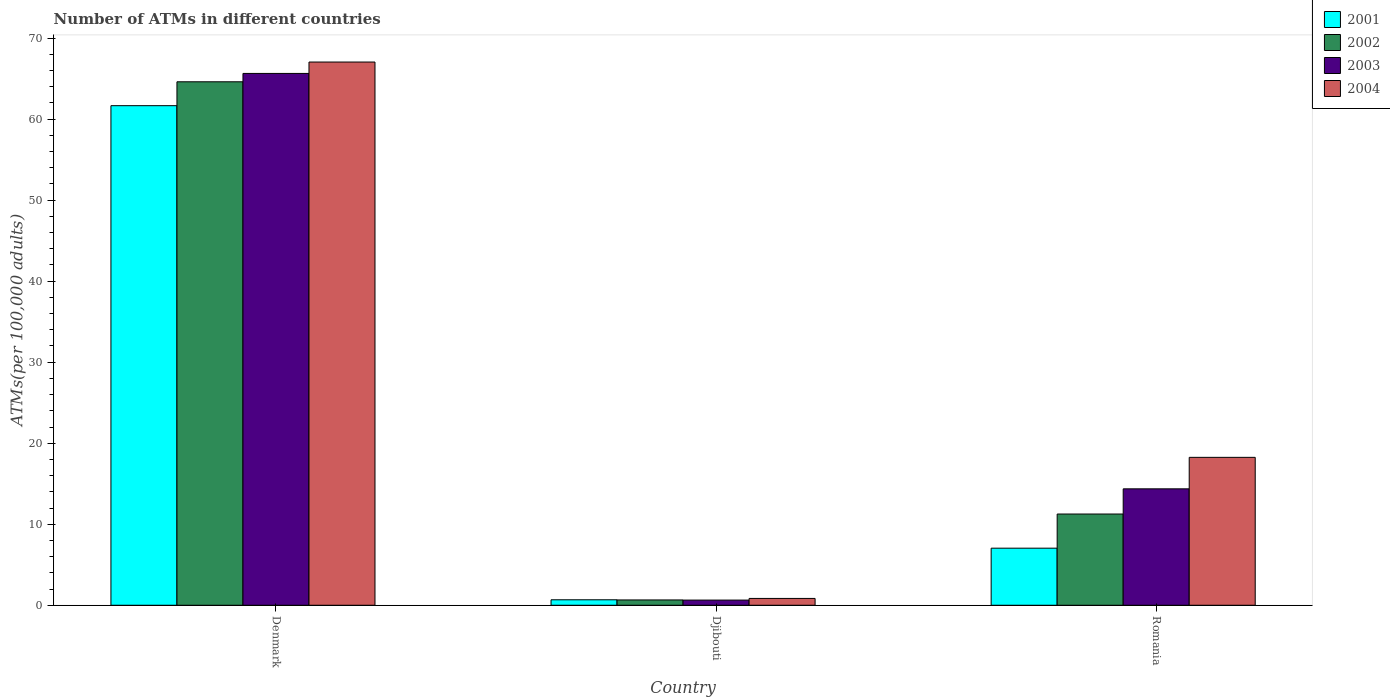How many different coloured bars are there?
Your answer should be very brief. 4. How many groups of bars are there?
Give a very brief answer. 3. Are the number of bars per tick equal to the number of legend labels?
Ensure brevity in your answer.  Yes. How many bars are there on the 1st tick from the right?
Ensure brevity in your answer.  4. In how many cases, is the number of bars for a given country not equal to the number of legend labels?
Your answer should be very brief. 0. What is the number of ATMs in 2001 in Romania?
Your answer should be very brief. 7.04. Across all countries, what is the maximum number of ATMs in 2001?
Keep it short and to the point. 61.66. Across all countries, what is the minimum number of ATMs in 2004?
Make the answer very short. 0.84. In which country was the number of ATMs in 2001 maximum?
Give a very brief answer. Denmark. In which country was the number of ATMs in 2001 minimum?
Provide a short and direct response. Djibouti. What is the total number of ATMs in 2004 in the graph?
Make the answer very short. 86.14. What is the difference between the number of ATMs in 2004 in Denmark and that in Romania?
Offer a terse response. 48.79. What is the difference between the number of ATMs in 2004 in Denmark and the number of ATMs in 2003 in Romania?
Give a very brief answer. 52.67. What is the average number of ATMs in 2002 per country?
Your answer should be compact. 25.51. What is the difference between the number of ATMs of/in 2004 and number of ATMs of/in 2002 in Romania?
Keep it short and to the point. 7. In how many countries, is the number of ATMs in 2001 greater than 34?
Give a very brief answer. 1. What is the ratio of the number of ATMs in 2002 in Denmark to that in Romania?
Your answer should be compact. 5.74. Is the number of ATMs in 2003 in Denmark less than that in Romania?
Your answer should be very brief. No. What is the difference between the highest and the second highest number of ATMs in 2001?
Keep it short and to the point. -60.98. What is the difference between the highest and the lowest number of ATMs in 2002?
Give a very brief answer. 63.95. Is the sum of the number of ATMs in 2003 in Djibouti and Romania greater than the maximum number of ATMs in 2004 across all countries?
Keep it short and to the point. No. Is it the case that in every country, the sum of the number of ATMs in 2003 and number of ATMs in 2001 is greater than the sum of number of ATMs in 2002 and number of ATMs in 2004?
Provide a short and direct response. No. What does the 1st bar from the left in Denmark represents?
Ensure brevity in your answer.  2001. What does the 2nd bar from the right in Denmark represents?
Keep it short and to the point. 2003. Is it the case that in every country, the sum of the number of ATMs in 2002 and number of ATMs in 2004 is greater than the number of ATMs in 2003?
Offer a very short reply. Yes. Are all the bars in the graph horizontal?
Offer a terse response. No. What is the difference between two consecutive major ticks on the Y-axis?
Make the answer very short. 10. Are the values on the major ticks of Y-axis written in scientific E-notation?
Provide a short and direct response. No. How many legend labels are there?
Keep it short and to the point. 4. How are the legend labels stacked?
Give a very brief answer. Vertical. What is the title of the graph?
Offer a terse response. Number of ATMs in different countries. What is the label or title of the X-axis?
Your answer should be very brief. Country. What is the label or title of the Y-axis?
Provide a short and direct response. ATMs(per 100,0 adults). What is the ATMs(per 100,000 adults) of 2001 in Denmark?
Provide a short and direct response. 61.66. What is the ATMs(per 100,000 adults) of 2002 in Denmark?
Provide a succinct answer. 64.61. What is the ATMs(per 100,000 adults) of 2003 in Denmark?
Provide a succinct answer. 65.64. What is the ATMs(per 100,000 adults) in 2004 in Denmark?
Offer a terse response. 67.04. What is the ATMs(per 100,000 adults) in 2001 in Djibouti?
Give a very brief answer. 0.68. What is the ATMs(per 100,000 adults) in 2002 in Djibouti?
Your answer should be very brief. 0.66. What is the ATMs(per 100,000 adults) in 2003 in Djibouti?
Your response must be concise. 0.64. What is the ATMs(per 100,000 adults) in 2004 in Djibouti?
Your answer should be compact. 0.84. What is the ATMs(per 100,000 adults) in 2001 in Romania?
Give a very brief answer. 7.04. What is the ATMs(per 100,000 adults) of 2002 in Romania?
Your answer should be compact. 11.26. What is the ATMs(per 100,000 adults) in 2003 in Romania?
Give a very brief answer. 14.37. What is the ATMs(per 100,000 adults) of 2004 in Romania?
Keep it short and to the point. 18.26. Across all countries, what is the maximum ATMs(per 100,000 adults) in 2001?
Offer a terse response. 61.66. Across all countries, what is the maximum ATMs(per 100,000 adults) in 2002?
Provide a short and direct response. 64.61. Across all countries, what is the maximum ATMs(per 100,000 adults) of 2003?
Your response must be concise. 65.64. Across all countries, what is the maximum ATMs(per 100,000 adults) of 2004?
Provide a short and direct response. 67.04. Across all countries, what is the minimum ATMs(per 100,000 adults) of 2001?
Make the answer very short. 0.68. Across all countries, what is the minimum ATMs(per 100,000 adults) of 2002?
Your response must be concise. 0.66. Across all countries, what is the minimum ATMs(per 100,000 adults) of 2003?
Keep it short and to the point. 0.64. Across all countries, what is the minimum ATMs(per 100,000 adults) in 2004?
Make the answer very short. 0.84. What is the total ATMs(per 100,000 adults) in 2001 in the graph?
Your answer should be very brief. 69.38. What is the total ATMs(per 100,000 adults) in 2002 in the graph?
Provide a short and direct response. 76.52. What is the total ATMs(per 100,000 adults) of 2003 in the graph?
Offer a terse response. 80.65. What is the total ATMs(per 100,000 adults) in 2004 in the graph?
Offer a terse response. 86.14. What is the difference between the ATMs(per 100,000 adults) of 2001 in Denmark and that in Djibouti?
Make the answer very short. 60.98. What is the difference between the ATMs(per 100,000 adults) of 2002 in Denmark and that in Djibouti?
Provide a succinct answer. 63.95. What is the difference between the ATMs(per 100,000 adults) in 2003 in Denmark and that in Djibouti?
Provide a succinct answer. 65. What is the difference between the ATMs(per 100,000 adults) in 2004 in Denmark and that in Djibouti?
Offer a very short reply. 66.2. What is the difference between the ATMs(per 100,000 adults) in 2001 in Denmark and that in Romania?
Provide a succinct answer. 54.61. What is the difference between the ATMs(per 100,000 adults) in 2002 in Denmark and that in Romania?
Offer a terse response. 53.35. What is the difference between the ATMs(per 100,000 adults) of 2003 in Denmark and that in Romania?
Make the answer very short. 51.27. What is the difference between the ATMs(per 100,000 adults) in 2004 in Denmark and that in Romania?
Offer a terse response. 48.79. What is the difference between the ATMs(per 100,000 adults) in 2001 in Djibouti and that in Romania?
Provide a succinct answer. -6.37. What is the difference between the ATMs(per 100,000 adults) in 2002 in Djibouti and that in Romania?
Your answer should be very brief. -10.6. What is the difference between the ATMs(per 100,000 adults) in 2003 in Djibouti and that in Romania?
Your answer should be compact. -13.73. What is the difference between the ATMs(per 100,000 adults) in 2004 in Djibouti and that in Romania?
Give a very brief answer. -17.41. What is the difference between the ATMs(per 100,000 adults) of 2001 in Denmark and the ATMs(per 100,000 adults) of 2002 in Djibouti?
Your response must be concise. 61. What is the difference between the ATMs(per 100,000 adults) of 2001 in Denmark and the ATMs(per 100,000 adults) of 2003 in Djibouti?
Offer a terse response. 61.02. What is the difference between the ATMs(per 100,000 adults) of 2001 in Denmark and the ATMs(per 100,000 adults) of 2004 in Djibouti?
Make the answer very short. 60.81. What is the difference between the ATMs(per 100,000 adults) in 2002 in Denmark and the ATMs(per 100,000 adults) in 2003 in Djibouti?
Provide a short and direct response. 63.97. What is the difference between the ATMs(per 100,000 adults) in 2002 in Denmark and the ATMs(per 100,000 adults) in 2004 in Djibouti?
Provide a succinct answer. 63.76. What is the difference between the ATMs(per 100,000 adults) of 2003 in Denmark and the ATMs(per 100,000 adults) of 2004 in Djibouti?
Your answer should be very brief. 64.79. What is the difference between the ATMs(per 100,000 adults) in 2001 in Denmark and the ATMs(per 100,000 adults) in 2002 in Romania?
Ensure brevity in your answer.  50.4. What is the difference between the ATMs(per 100,000 adults) in 2001 in Denmark and the ATMs(per 100,000 adults) in 2003 in Romania?
Offer a terse response. 47.29. What is the difference between the ATMs(per 100,000 adults) in 2001 in Denmark and the ATMs(per 100,000 adults) in 2004 in Romania?
Ensure brevity in your answer.  43.4. What is the difference between the ATMs(per 100,000 adults) in 2002 in Denmark and the ATMs(per 100,000 adults) in 2003 in Romania?
Make the answer very short. 50.24. What is the difference between the ATMs(per 100,000 adults) of 2002 in Denmark and the ATMs(per 100,000 adults) of 2004 in Romania?
Your response must be concise. 46.35. What is the difference between the ATMs(per 100,000 adults) in 2003 in Denmark and the ATMs(per 100,000 adults) in 2004 in Romania?
Make the answer very short. 47.38. What is the difference between the ATMs(per 100,000 adults) in 2001 in Djibouti and the ATMs(per 100,000 adults) in 2002 in Romania?
Make the answer very short. -10.58. What is the difference between the ATMs(per 100,000 adults) of 2001 in Djibouti and the ATMs(per 100,000 adults) of 2003 in Romania?
Make the answer very short. -13.69. What is the difference between the ATMs(per 100,000 adults) of 2001 in Djibouti and the ATMs(per 100,000 adults) of 2004 in Romania?
Offer a very short reply. -17.58. What is the difference between the ATMs(per 100,000 adults) of 2002 in Djibouti and the ATMs(per 100,000 adults) of 2003 in Romania?
Provide a short and direct response. -13.71. What is the difference between the ATMs(per 100,000 adults) of 2002 in Djibouti and the ATMs(per 100,000 adults) of 2004 in Romania?
Provide a succinct answer. -17.6. What is the difference between the ATMs(per 100,000 adults) in 2003 in Djibouti and the ATMs(per 100,000 adults) in 2004 in Romania?
Offer a very short reply. -17.62. What is the average ATMs(per 100,000 adults) in 2001 per country?
Keep it short and to the point. 23.13. What is the average ATMs(per 100,000 adults) of 2002 per country?
Your answer should be compact. 25.51. What is the average ATMs(per 100,000 adults) in 2003 per country?
Your response must be concise. 26.88. What is the average ATMs(per 100,000 adults) in 2004 per country?
Keep it short and to the point. 28.71. What is the difference between the ATMs(per 100,000 adults) of 2001 and ATMs(per 100,000 adults) of 2002 in Denmark?
Your answer should be very brief. -2.95. What is the difference between the ATMs(per 100,000 adults) of 2001 and ATMs(per 100,000 adults) of 2003 in Denmark?
Your answer should be very brief. -3.98. What is the difference between the ATMs(per 100,000 adults) of 2001 and ATMs(per 100,000 adults) of 2004 in Denmark?
Ensure brevity in your answer.  -5.39. What is the difference between the ATMs(per 100,000 adults) of 2002 and ATMs(per 100,000 adults) of 2003 in Denmark?
Your answer should be very brief. -1.03. What is the difference between the ATMs(per 100,000 adults) of 2002 and ATMs(per 100,000 adults) of 2004 in Denmark?
Keep it short and to the point. -2.44. What is the difference between the ATMs(per 100,000 adults) in 2003 and ATMs(per 100,000 adults) in 2004 in Denmark?
Offer a terse response. -1.41. What is the difference between the ATMs(per 100,000 adults) in 2001 and ATMs(per 100,000 adults) in 2002 in Djibouti?
Offer a terse response. 0.02. What is the difference between the ATMs(per 100,000 adults) in 2001 and ATMs(per 100,000 adults) in 2003 in Djibouti?
Provide a succinct answer. 0.04. What is the difference between the ATMs(per 100,000 adults) of 2001 and ATMs(per 100,000 adults) of 2004 in Djibouti?
Your answer should be very brief. -0.17. What is the difference between the ATMs(per 100,000 adults) of 2002 and ATMs(per 100,000 adults) of 2003 in Djibouti?
Offer a terse response. 0.02. What is the difference between the ATMs(per 100,000 adults) of 2002 and ATMs(per 100,000 adults) of 2004 in Djibouti?
Offer a terse response. -0.19. What is the difference between the ATMs(per 100,000 adults) of 2003 and ATMs(per 100,000 adults) of 2004 in Djibouti?
Offer a very short reply. -0.21. What is the difference between the ATMs(per 100,000 adults) in 2001 and ATMs(per 100,000 adults) in 2002 in Romania?
Your response must be concise. -4.21. What is the difference between the ATMs(per 100,000 adults) of 2001 and ATMs(per 100,000 adults) of 2003 in Romania?
Keep it short and to the point. -7.32. What is the difference between the ATMs(per 100,000 adults) of 2001 and ATMs(per 100,000 adults) of 2004 in Romania?
Your answer should be very brief. -11.21. What is the difference between the ATMs(per 100,000 adults) in 2002 and ATMs(per 100,000 adults) in 2003 in Romania?
Make the answer very short. -3.11. What is the difference between the ATMs(per 100,000 adults) of 2002 and ATMs(per 100,000 adults) of 2004 in Romania?
Offer a very short reply. -7. What is the difference between the ATMs(per 100,000 adults) of 2003 and ATMs(per 100,000 adults) of 2004 in Romania?
Your answer should be very brief. -3.89. What is the ratio of the ATMs(per 100,000 adults) of 2001 in Denmark to that in Djibouti?
Keep it short and to the point. 91.18. What is the ratio of the ATMs(per 100,000 adults) in 2002 in Denmark to that in Djibouti?
Your answer should be very brief. 98.45. What is the ratio of the ATMs(per 100,000 adults) of 2003 in Denmark to that in Djibouti?
Make the answer very short. 102.88. What is the ratio of the ATMs(per 100,000 adults) of 2004 in Denmark to that in Djibouti?
Provide a succinct answer. 79.46. What is the ratio of the ATMs(per 100,000 adults) in 2001 in Denmark to that in Romania?
Provide a succinct answer. 8.75. What is the ratio of the ATMs(per 100,000 adults) of 2002 in Denmark to that in Romania?
Give a very brief answer. 5.74. What is the ratio of the ATMs(per 100,000 adults) in 2003 in Denmark to that in Romania?
Offer a terse response. 4.57. What is the ratio of the ATMs(per 100,000 adults) in 2004 in Denmark to that in Romania?
Give a very brief answer. 3.67. What is the ratio of the ATMs(per 100,000 adults) of 2001 in Djibouti to that in Romania?
Your response must be concise. 0.1. What is the ratio of the ATMs(per 100,000 adults) in 2002 in Djibouti to that in Romania?
Provide a short and direct response. 0.06. What is the ratio of the ATMs(per 100,000 adults) of 2003 in Djibouti to that in Romania?
Provide a succinct answer. 0.04. What is the ratio of the ATMs(per 100,000 adults) in 2004 in Djibouti to that in Romania?
Give a very brief answer. 0.05. What is the difference between the highest and the second highest ATMs(per 100,000 adults) of 2001?
Provide a succinct answer. 54.61. What is the difference between the highest and the second highest ATMs(per 100,000 adults) in 2002?
Provide a succinct answer. 53.35. What is the difference between the highest and the second highest ATMs(per 100,000 adults) in 2003?
Provide a short and direct response. 51.27. What is the difference between the highest and the second highest ATMs(per 100,000 adults) in 2004?
Your answer should be very brief. 48.79. What is the difference between the highest and the lowest ATMs(per 100,000 adults) of 2001?
Offer a very short reply. 60.98. What is the difference between the highest and the lowest ATMs(per 100,000 adults) of 2002?
Provide a short and direct response. 63.95. What is the difference between the highest and the lowest ATMs(per 100,000 adults) in 2003?
Make the answer very short. 65. What is the difference between the highest and the lowest ATMs(per 100,000 adults) in 2004?
Your answer should be compact. 66.2. 